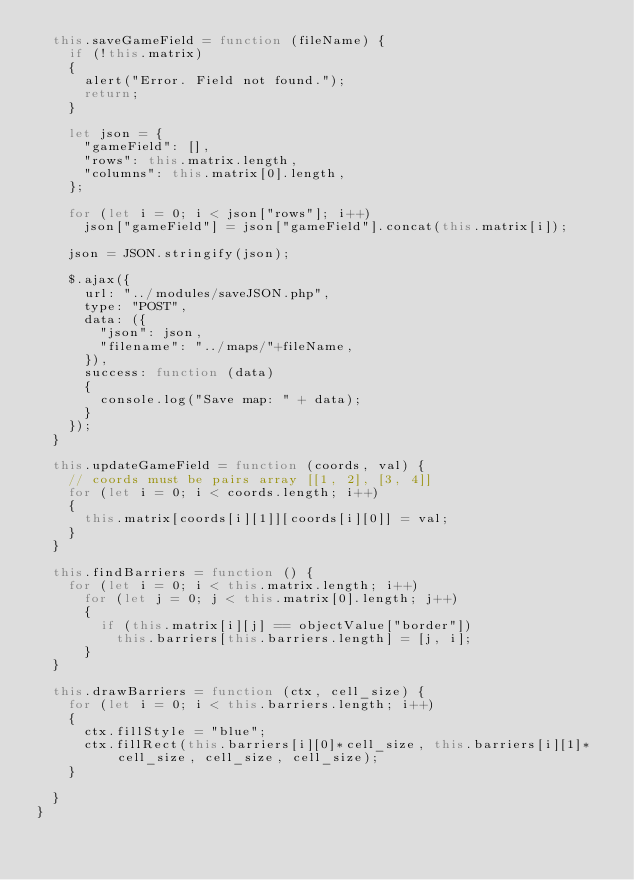Convert code to text. <code><loc_0><loc_0><loc_500><loc_500><_JavaScript_>	this.saveGameField = function (fileName) {
		if (!this.matrix)
		{
			alert("Error. Field not found.");
			return;
		}

		let json = {
			"gameField": [],
			"rows": this.matrix.length,
			"columns": this.matrix[0].length,
		};

		for (let i = 0; i < json["rows"]; i++)
			json["gameField"] = json["gameField"].concat(this.matrix[i]);

		json = JSON.stringify(json);

		$.ajax({
			url: "../modules/saveJSON.php",
			type: "POST",
			data: ({
				"json": json,
				"filename": "../maps/"+fileName,
			}),
			success: function (data)
			{
				console.log("Save map: " + data);
			} 
		});
	}

	this.updateGameField = function (coords, val) {
		// coords must be pairs array [[1, 2], [3, 4]]
		for (let i = 0; i < coords.length; i++)
		{
			this.matrix[coords[i][1]][coords[i][0]] = val; 
		}
	}

	this.findBarriers = function () {
		for (let i = 0; i < this.matrix.length; i++)
			for (let j = 0; j < this.matrix[0].length; j++)
			{
				if (this.matrix[i][j] == objectValue["border"])
					this.barriers[this.barriers.length] = [j, i];
			}
	}

	this.drawBarriers = function (ctx, cell_size) {
		for (let i = 0; i < this.barriers.length; i++)
		{
			ctx.fillStyle = "blue";
			ctx.fillRect(this.barriers[i][0]*cell_size, this.barriers[i][1]*cell_size, cell_size, cell_size);
		}

	}
}</code> 